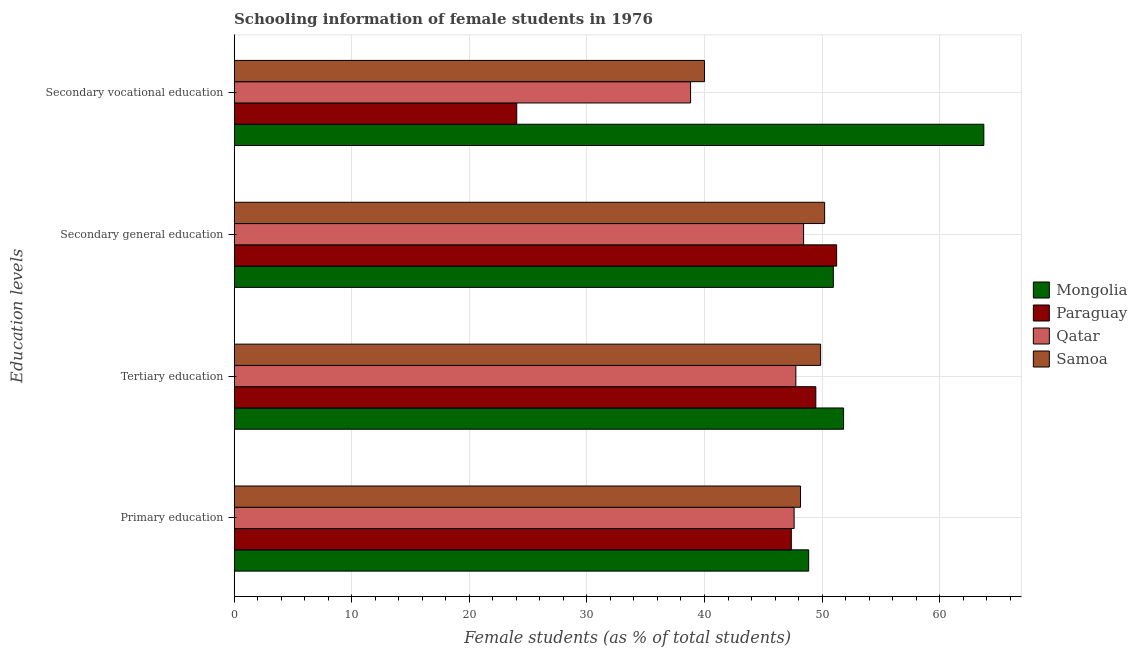How many different coloured bars are there?
Give a very brief answer. 4. How many groups of bars are there?
Ensure brevity in your answer.  4. Are the number of bars on each tick of the Y-axis equal?
Your response must be concise. Yes. How many bars are there on the 1st tick from the top?
Provide a short and direct response. 4. What is the label of the 4th group of bars from the top?
Offer a very short reply. Primary education. What is the percentage of female students in secondary vocational education in Qatar?
Provide a short and direct response. 38.82. Across all countries, what is the maximum percentage of female students in tertiary education?
Provide a succinct answer. 51.83. Across all countries, what is the minimum percentage of female students in tertiary education?
Your response must be concise. 47.77. In which country was the percentage of female students in secondary education maximum?
Make the answer very short. Paraguay. In which country was the percentage of female students in secondary vocational education minimum?
Offer a terse response. Paraguay. What is the total percentage of female students in tertiary education in the graph?
Ensure brevity in your answer.  198.94. What is the difference between the percentage of female students in secondary vocational education in Mongolia and that in Paraguay?
Keep it short and to the point. 39.72. What is the difference between the percentage of female students in secondary vocational education in Samoa and the percentage of female students in tertiary education in Paraguay?
Give a very brief answer. -9.47. What is the average percentage of female students in secondary vocational education per country?
Your answer should be very brief. 41.65. What is the difference between the percentage of female students in secondary vocational education and percentage of female students in primary education in Paraguay?
Your answer should be compact. -23.35. What is the ratio of the percentage of female students in primary education in Mongolia to that in Paraguay?
Provide a succinct answer. 1.03. What is the difference between the highest and the second highest percentage of female students in primary education?
Your response must be concise. 0.69. What is the difference between the highest and the lowest percentage of female students in primary education?
Your response must be concise. 1.48. In how many countries, is the percentage of female students in secondary education greater than the average percentage of female students in secondary education taken over all countries?
Make the answer very short. 3. What does the 4th bar from the top in Secondary general education represents?
Provide a short and direct response. Mongolia. What does the 2nd bar from the bottom in Tertiary education represents?
Your response must be concise. Paraguay. Is it the case that in every country, the sum of the percentage of female students in primary education and percentage of female students in tertiary education is greater than the percentage of female students in secondary education?
Offer a very short reply. Yes. Are all the bars in the graph horizontal?
Offer a very short reply. Yes. What is the difference between two consecutive major ticks on the X-axis?
Provide a succinct answer. 10. Are the values on the major ticks of X-axis written in scientific E-notation?
Give a very brief answer. No. Does the graph contain any zero values?
Make the answer very short. No. Where does the legend appear in the graph?
Your answer should be compact. Center right. How many legend labels are there?
Keep it short and to the point. 4. How are the legend labels stacked?
Offer a terse response. Vertical. What is the title of the graph?
Provide a short and direct response. Schooling information of female students in 1976. Does "Kenya" appear as one of the legend labels in the graph?
Give a very brief answer. No. What is the label or title of the X-axis?
Your answer should be very brief. Female students (as % of total students). What is the label or title of the Y-axis?
Offer a very short reply. Education levels. What is the Female students (as % of total students) of Mongolia in Primary education?
Your response must be concise. 48.86. What is the Female students (as % of total students) of Paraguay in Primary education?
Provide a succinct answer. 47.38. What is the Female students (as % of total students) in Qatar in Primary education?
Your answer should be very brief. 47.62. What is the Female students (as % of total students) of Samoa in Primary education?
Keep it short and to the point. 48.17. What is the Female students (as % of total students) of Mongolia in Tertiary education?
Your answer should be very brief. 51.83. What is the Female students (as % of total students) of Paraguay in Tertiary education?
Your answer should be compact. 49.47. What is the Female students (as % of total students) in Qatar in Tertiary education?
Keep it short and to the point. 47.77. What is the Female students (as % of total students) of Samoa in Tertiary education?
Make the answer very short. 49.87. What is the Female students (as % of total students) of Mongolia in Secondary general education?
Your response must be concise. 50.96. What is the Female students (as % of total students) of Paraguay in Secondary general education?
Make the answer very short. 51.24. What is the Female students (as % of total students) of Qatar in Secondary general education?
Offer a very short reply. 48.43. What is the Female students (as % of total students) of Samoa in Secondary general education?
Your answer should be very brief. 50.22. What is the Female students (as % of total students) in Mongolia in Secondary vocational education?
Offer a very short reply. 63.76. What is the Female students (as % of total students) of Paraguay in Secondary vocational education?
Provide a short and direct response. 24.03. What is the Female students (as % of total students) of Qatar in Secondary vocational education?
Your answer should be very brief. 38.82. Across all Education levels, what is the maximum Female students (as % of total students) in Mongolia?
Give a very brief answer. 63.76. Across all Education levels, what is the maximum Female students (as % of total students) of Paraguay?
Offer a terse response. 51.24. Across all Education levels, what is the maximum Female students (as % of total students) in Qatar?
Keep it short and to the point. 48.43. Across all Education levels, what is the maximum Female students (as % of total students) of Samoa?
Offer a terse response. 50.22. Across all Education levels, what is the minimum Female students (as % of total students) of Mongolia?
Make the answer very short. 48.86. Across all Education levels, what is the minimum Female students (as % of total students) of Paraguay?
Ensure brevity in your answer.  24.03. Across all Education levels, what is the minimum Female students (as % of total students) in Qatar?
Your answer should be very brief. 38.82. What is the total Female students (as % of total students) of Mongolia in the graph?
Your response must be concise. 215.4. What is the total Female students (as % of total students) of Paraguay in the graph?
Keep it short and to the point. 172.12. What is the total Female students (as % of total students) in Qatar in the graph?
Give a very brief answer. 182.64. What is the total Female students (as % of total students) in Samoa in the graph?
Provide a short and direct response. 188.26. What is the difference between the Female students (as % of total students) in Mongolia in Primary education and that in Tertiary education?
Give a very brief answer. -2.97. What is the difference between the Female students (as % of total students) of Paraguay in Primary education and that in Tertiary education?
Give a very brief answer. -2.08. What is the difference between the Female students (as % of total students) in Qatar in Primary education and that in Tertiary education?
Ensure brevity in your answer.  -0.15. What is the difference between the Female students (as % of total students) in Samoa in Primary education and that in Tertiary education?
Make the answer very short. -1.71. What is the difference between the Female students (as % of total students) in Mongolia in Primary education and that in Secondary general education?
Your answer should be compact. -2.1. What is the difference between the Female students (as % of total students) in Paraguay in Primary education and that in Secondary general education?
Provide a short and direct response. -3.85. What is the difference between the Female students (as % of total students) in Qatar in Primary education and that in Secondary general education?
Provide a succinct answer. -0.81. What is the difference between the Female students (as % of total students) of Samoa in Primary education and that in Secondary general education?
Give a very brief answer. -2.05. What is the difference between the Female students (as % of total students) of Mongolia in Primary education and that in Secondary vocational education?
Your answer should be very brief. -14.9. What is the difference between the Female students (as % of total students) in Paraguay in Primary education and that in Secondary vocational education?
Your response must be concise. 23.35. What is the difference between the Female students (as % of total students) in Qatar in Primary education and that in Secondary vocational education?
Keep it short and to the point. 8.81. What is the difference between the Female students (as % of total students) in Samoa in Primary education and that in Secondary vocational education?
Keep it short and to the point. 8.17. What is the difference between the Female students (as % of total students) in Mongolia in Tertiary education and that in Secondary general education?
Offer a very short reply. 0.87. What is the difference between the Female students (as % of total students) of Paraguay in Tertiary education and that in Secondary general education?
Your answer should be very brief. -1.77. What is the difference between the Female students (as % of total students) of Qatar in Tertiary education and that in Secondary general education?
Offer a very short reply. -0.66. What is the difference between the Female students (as % of total students) of Samoa in Tertiary education and that in Secondary general education?
Ensure brevity in your answer.  -0.34. What is the difference between the Female students (as % of total students) in Mongolia in Tertiary education and that in Secondary vocational education?
Make the answer very short. -11.93. What is the difference between the Female students (as % of total students) in Paraguay in Tertiary education and that in Secondary vocational education?
Keep it short and to the point. 25.43. What is the difference between the Female students (as % of total students) of Qatar in Tertiary education and that in Secondary vocational education?
Your answer should be compact. 8.95. What is the difference between the Female students (as % of total students) of Samoa in Tertiary education and that in Secondary vocational education?
Give a very brief answer. 9.87. What is the difference between the Female students (as % of total students) in Mongolia in Secondary general education and that in Secondary vocational education?
Offer a terse response. -12.8. What is the difference between the Female students (as % of total students) in Paraguay in Secondary general education and that in Secondary vocational education?
Provide a short and direct response. 27.2. What is the difference between the Female students (as % of total students) in Qatar in Secondary general education and that in Secondary vocational education?
Your answer should be very brief. 9.61. What is the difference between the Female students (as % of total students) of Samoa in Secondary general education and that in Secondary vocational education?
Offer a very short reply. 10.22. What is the difference between the Female students (as % of total students) of Mongolia in Primary education and the Female students (as % of total students) of Paraguay in Tertiary education?
Ensure brevity in your answer.  -0.61. What is the difference between the Female students (as % of total students) in Mongolia in Primary education and the Female students (as % of total students) in Qatar in Tertiary education?
Give a very brief answer. 1.09. What is the difference between the Female students (as % of total students) in Mongolia in Primary education and the Female students (as % of total students) in Samoa in Tertiary education?
Your answer should be compact. -1.02. What is the difference between the Female students (as % of total students) of Paraguay in Primary education and the Female students (as % of total students) of Qatar in Tertiary education?
Offer a terse response. -0.39. What is the difference between the Female students (as % of total students) in Paraguay in Primary education and the Female students (as % of total students) in Samoa in Tertiary education?
Make the answer very short. -2.49. What is the difference between the Female students (as % of total students) of Qatar in Primary education and the Female students (as % of total students) of Samoa in Tertiary education?
Make the answer very short. -2.25. What is the difference between the Female students (as % of total students) in Mongolia in Primary education and the Female students (as % of total students) in Paraguay in Secondary general education?
Offer a very short reply. -2.38. What is the difference between the Female students (as % of total students) in Mongolia in Primary education and the Female students (as % of total students) in Qatar in Secondary general education?
Provide a short and direct response. 0.43. What is the difference between the Female students (as % of total students) of Mongolia in Primary education and the Female students (as % of total students) of Samoa in Secondary general education?
Your answer should be compact. -1.36. What is the difference between the Female students (as % of total students) in Paraguay in Primary education and the Female students (as % of total students) in Qatar in Secondary general education?
Provide a short and direct response. -1.04. What is the difference between the Female students (as % of total students) of Paraguay in Primary education and the Female students (as % of total students) of Samoa in Secondary general education?
Ensure brevity in your answer.  -2.83. What is the difference between the Female students (as % of total students) in Qatar in Primary education and the Female students (as % of total students) in Samoa in Secondary general education?
Provide a short and direct response. -2.59. What is the difference between the Female students (as % of total students) of Mongolia in Primary education and the Female students (as % of total students) of Paraguay in Secondary vocational education?
Give a very brief answer. 24.83. What is the difference between the Female students (as % of total students) of Mongolia in Primary education and the Female students (as % of total students) of Qatar in Secondary vocational education?
Keep it short and to the point. 10.04. What is the difference between the Female students (as % of total students) of Mongolia in Primary education and the Female students (as % of total students) of Samoa in Secondary vocational education?
Provide a short and direct response. 8.86. What is the difference between the Female students (as % of total students) in Paraguay in Primary education and the Female students (as % of total students) in Qatar in Secondary vocational education?
Offer a terse response. 8.57. What is the difference between the Female students (as % of total students) in Paraguay in Primary education and the Female students (as % of total students) in Samoa in Secondary vocational education?
Give a very brief answer. 7.38. What is the difference between the Female students (as % of total students) of Qatar in Primary education and the Female students (as % of total students) of Samoa in Secondary vocational education?
Offer a terse response. 7.62. What is the difference between the Female students (as % of total students) in Mongolia in Tertiary education and the Female students (as % of total students) in Paraguay in Secondary general education?
Ensure brevity in your answer.  0.59. What is the difference between the Female students (as % of total students) in Mongolia in Tertiary education and the Female students (as % of total students) in Qatar in Secondary general education?
Provide a short and direct response. 3.4. What is the difference between the Female students (as % of total students) of Mongolia in Tertiary education and the Female students (as % of total students) of Samoa in Secondary general education?
Provide a succinct answer. 1.61. What is the difference between the Female students (as % of total students) of Paraguay in Tertiary education and the Female students (as % of total students) of Qatar in Secondary general education?
Offer a very short reply. 1.04. What is the difference between the Female students (as % of total students) of Paraguay in Tertiary education and the Female students (as % of total students) of Samoa in Secondary general education?
Give a very brief answer. -0.75. What is the difference between the Female students (as % of total students) in Qatar in Tertiary education and the Female students (as % of total students) in Samoa in Secondary general education?
Keep it short and to the point. -2.45. What is the difference between the Female students (as % of total students) of Mongolia in Tertiary education and the Female students (as % of total students) of Paraguay in Secondary vocational education?
Ensure brevity in your answer.  27.79. What is the difference between the Female students (as % of total students) of Mongolia in Tertiary education and the Female students (as % of total students) of Qatar in Secondary vocational education?
Make the answer very short. 13.01. What is the difference between the Female students (as % of total students) in Mongolia in Tertiary education and the Female students (as % of total students) in Samoa in Secondary vocational education?
Keep it short and to the point. 11.83. What is the difference between the Female students (as % of total students) in Paraguay in Tertiary education and the Female students (as % of total students) in Qatar in Secondary vocational education?
Provide a succinct answer. 10.65. What is the difference between the Female students (as % of total students) in Paraguay in Tertiary education and the Female students (as % of total students) in Samoa in Secondary vocational education?
Your response must be concise. 9.47. What is the difference between the Female students (as % of total students) in Qatar in Tertiary education and the Female students (as % of total students) in Samoa in Secondary vocational education?
Make the answer very short. 7.77. What is the difference between the Female students (as % of total students) of Mongolia in Secondary general education and the Female students (as % of total students) of Paraguay in Secondary vocational education?
Your answer should be very brief. 26.92. What is the difference between the Female students (as % of total students) in Mongolia in Secondary general education and the Female students (as % of total students) in Qatar in Secondary vocational education?
Make the answer very short. 12.14. What is the difference between the Female students (as % of total students) of Mongolia in Secondary general education and the Female students (as % of total students) of Samoa in Secondary vocational education?
Offer a very short reply. 10.96. What is the difference between the Female students (as % of total students) of Paraguay in Secondary general education and the Female students (as % of total students) of Qatar in Secondary vocational education?
Keep it short and to the point. 12.42. What is the difference between the Female students (as % of total students) of Paraguay in Secondary general education and the Female students (as % of total students) of Samoa in Secondary vocational education?
Give a very brief answer. 11.24. What is the difference between the Female students (as % of total students) of Qatar in Secondary general education and the Female students (as % of total students) of Samoa in Secondary vocational education?
Offer a terse response. 8.43. What is the average Female students (as % of total students) of Mongolia per Education levels?
Offer a terse response. 53.85. What is the average Female students (as % of total students) of Paraguay per Education levels?
Make the answer very short. 43.03. What is the average Female students (as % of total students) in Qatar per Education levels?
Provide a succinct answer. 45.66. What is the average Female students (as % of total students) of Samoa per Education levels?
Make the answer very short. 47.06. What is the difference between the Female students (as % of total students) in Mongolia and Female students (as % of total students) in Paraguay in Primary education?
Offer a very short reply. 1.48. What is the difference between the Female students (as % of total students) in Mongolia and Female students (as % of total students) in Qatar in Primary education?
Your answer should be compact. 1.24. What is the difference between the Female students (as % of total students) in Mongolia and Female students (as % of total students) in Samoa in Primary education?
Provide a short and direct response. 0.69. What is the difference between the Female students (as % of total students) of Paraguay and Female students (as % of total students) of Qatar in Primary education?
Make the answer very short. -0.24. What is the difference between the Female students (as % of total students) of Paraguay and Female students (as % of total students) of Samoa in Primary education?
Offer a terse response. -0.78. What is the difference between the Female students (as % of total students) of Qatar and Female students (as % of total students) of Samoa in Primary education?
Ensure brevity in your answer.  -0.55. What is the difference between the Female students (as % of total students) of Mongolia and Female students (as % of total students) of Paraguay in Tertiary education?
Keep it short and to the point. 2.36. What is the difference between the Female students (as % of total students) in Mongolia and Female students (as % of total students) in Qatar in Tertiary education?
Provide a succinct answer. 4.06. What is the difference between the Female students (as % of total students) in Mongolia and Female students (as % of total students) in Samoa in Tertiary education?
Your response must be concise. 1.95. What is the difference between the Female students (as % of total students) of Paraguay and Female students (as % of total students) of Qatar in Tertiary education?
Ensure brevity in your answer.  1.7. What is the difference between the Female students (as % of total students) in Paraguay and Female students (as % of total students) in Samoa in Tertiary education?
Give a very brief answer. -0.41. What is the difference between the Female students (as % of total students) of Qatar and Female students (as % of total students) of Samoa in Tertiary education?
Offer a terse response. -2.11. What is the difference between the Female students (as % of total students) of Mongolia and Female students (as % of total students) of Paraguay in Secondary general education?
Your answer should be very brief. -0.28. What is the difference between the Female students (as % of total students) in Mongolia and Female students (as % of total students) in Qatar in Secondary general education?
Your response must be concise. 2.53. What is the difference between the Female students (as % of total students) in Mongolia and Female students (as % of total students) in Samoa in Secondary general education?
Your answer should be very brief. 0.74. What is the difference between the Female students (as % of total students) of Paraguay and Female students (as % of total students) of Qatar in Secondary general education?
Your answer should be compact. 2.81. What is the difference between the Female students (as % of total students) of Paraguay and Female students (as % of total students) of Samoa in Secondary general education?
Your answer should be compact. 1.02. What is the difference between the Female students (as % of total students) in Qatar and Female students (as % of total students) in Samoa in Secondary general education?
Your answer should be very brief. -1.79. What is the difference between the Female students (as % of total students) of Mongolia and Female students (as % of total students) of Paraguay in Secondary vocational education?
Provide a succinct answer. 39.72. What is the difference between the Female students (as % of total students) in Mongolia and Female students (as % of total students) in Qatar in Secondary vocational education?
Your answer should be compact. 24.94. What is the difference between the Female students (as % of total students) of Mongolia and Female students (as % of total students) of Samoa in Secondary vocational education?
Keep it short and to the point. 23.76. What is the difference between the Female students (as % of total students) of Paraguay and Female students (as % of total students) of Qatar in Secondary vocational education?
Keep it short and to the point. -14.78. What is the difference between the Female students (as % of total students) in Paraguay and Female students (as % of total students) in Samoa in Secondary vocational education?
Provide a succinct answer. -15.97. What is the difference between the Female students (as % of total students) of Qatar and Female students (as % of total students) of Samoa in Secondary vocational education?
Make the answer very short. -1.18. What is the ratio of the Female students (as % of total students) in Mongolia in Primary education to that in Tertiary education?
Offer a terse response. 0.94. What is the ratio of the Female students (as % of total students) in Paraguay in Primary education to that in Tertiary education?
Ensure brevity in your answer.  0.96. What is the ratio of the Female students (as % of total students) in Samoa in Primary education to that in Tertiary education?
Ensure brevity in your answer.  0.97. What is the ratio of the Female students (as % of total students) in Mongolia in Primary education to that in Secondary general education?
Keep it short and to the point. 0.96. What is the ratio of the Female students (as % of total students) in Paraguay in Primary education to that in Secondary general education?
Your response must be concise. 0.92. What is the ratio of the Female students (as % of total students) of Qatar in Primary education to that in Secondary general education?
Provide a short and direct response. 0.98. What is the ratio of the Female students (as % of total students) in Samoa in Primary education to that in Secondary general education?
Provide a succinct answer. 0.96. What is the ratio of the Female students (as % of total students) of Mongolia in Primary education to that in Secondary vocational education?
Provide a short and direct response. 0.77. What is the ratio of the Female students (as % of total students) of Paraguay in Primary education to that in Secondary vocational education?
Your answer should be compact. 1.97. What is the ratio of the Female students (as % of total students) in Qatar in Primary education to that in Secondary vocational education?
Keep it short and to the point. 1.23. What is the ratio of the Female students (as % of total students) of Samoa in Primary education to that in Secondary vocational education?
Keep it short and to the point. 1.2. What is the ratio of the Female students (as % of total students) of Mongolia in Tertiary education to that in Secondary general education?
Your answer should be compact. 1.02. What is the ratio of the Female students (as % of total students) of Paraguay in Tertiary education to that in Secondary general education?
Ensure brevity in your answer.  0.97. What is the ratio of the Female students (as % of total students) in Qatar in Tertiary education to that in Secondary general education?
Make the answer very short. 0.99. What is the ratio of the Female students (as % of total students) of Mongolia in Tertiary education to that in Secondary vocational education?
Provide a short and direct response. 0.81. What is the ratio of the Female students (as % of total students) in Paraguay in Tertiary education to that in Secondary vocational education?
Provide a succinct answer. 2.06. What is the ratio of the Female students (as % of total students) of Qatar in Tertiary education to that in Secondary vocational education?
Offer a terse response. 1.23. What is the ratio of the Female students (as % of total students) of Samoa in Tertiary education to that in Secondary vocational education?
Your answer should be compact. 1.25. What is the ratio of the Female students (as % of total students) in Mongolia in Secondary general education to that in Secondary vocational education?
Ensure brevity in your answer.  0.8. What is the ratio of the Female students (as % of total students) of Paraguay in Secondary general education to that in Secondary vocational education?
Keep it short and to the point. 2.13. What is the ratio of the Female students (as % of total students) of Qatar in Secondary general education to that in Secondary vocational education?
Your answer should be very brief. 1.25. What is the ratio of the Female students (as % of total students) of Samoa in Secondary general education to that in Secondary vocational education?
Provide a succinct answer. 1.26. What is the difference between the highest and the second highest Female students (as % of total students) of Mongolia?
Provide a short and direct response. 11.93. What is the difference between the highest and the second highest Female students (as % of total students) in Paraguay?
Your response must be concise. 1.77. What is the difference between the highest and the second highest Female students (as % of total students) in Qatar?
Offer a terse response. 0.66. What is the difference between the highest and the second highest Female students (as % of total students) in Samoa?
Provide a succinct answer. 0.34. What is the difference between the highest and the lowest Female students (as % of total students) of Mongolia?
Offer a very short reply. 14.9. What is the difference between the highest and the lowest Female students (as % of total students) of Paraguay?
Ensure brevity in your answer.  27.2. What is the difference between the highest and the lowest Female students (as % of total students) of Qatar?
Keep it short and to the point. 9.61. What is the difference between the highest and the lowest Female students (as % of total students) of Samoa?
Keep it short and to the point. 10.22. 